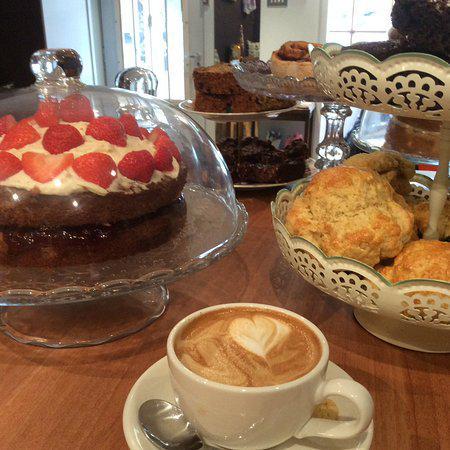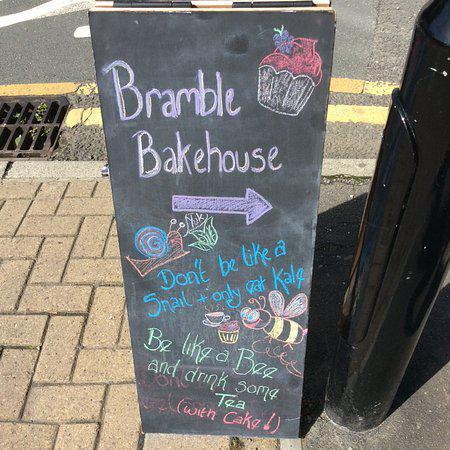The first image is the image on the left, the second image is the image on the right. Given the left and right images, does the statement "At least one saucer in the image on the left has a coffee cup on top of it." hold true? Answer yes or no. Yes. The first image is the image on the left, the second image is the image on the right. For the images displayed, is the sentence "Each image features baked treats displayed on tiered plates, and porcelain teapots are in the background of at least one image." factually correct? Answer yes or no. No. 